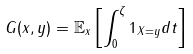Convert formula to latex. <formula><loc_0><loc_0><loc_500><loc_500>G ( x , y ) = \mathbb { E } _ { x } \left [ \int _ { 0 } ^ { \zeta } 1 _ { X = y } d t \right ]</formula> 